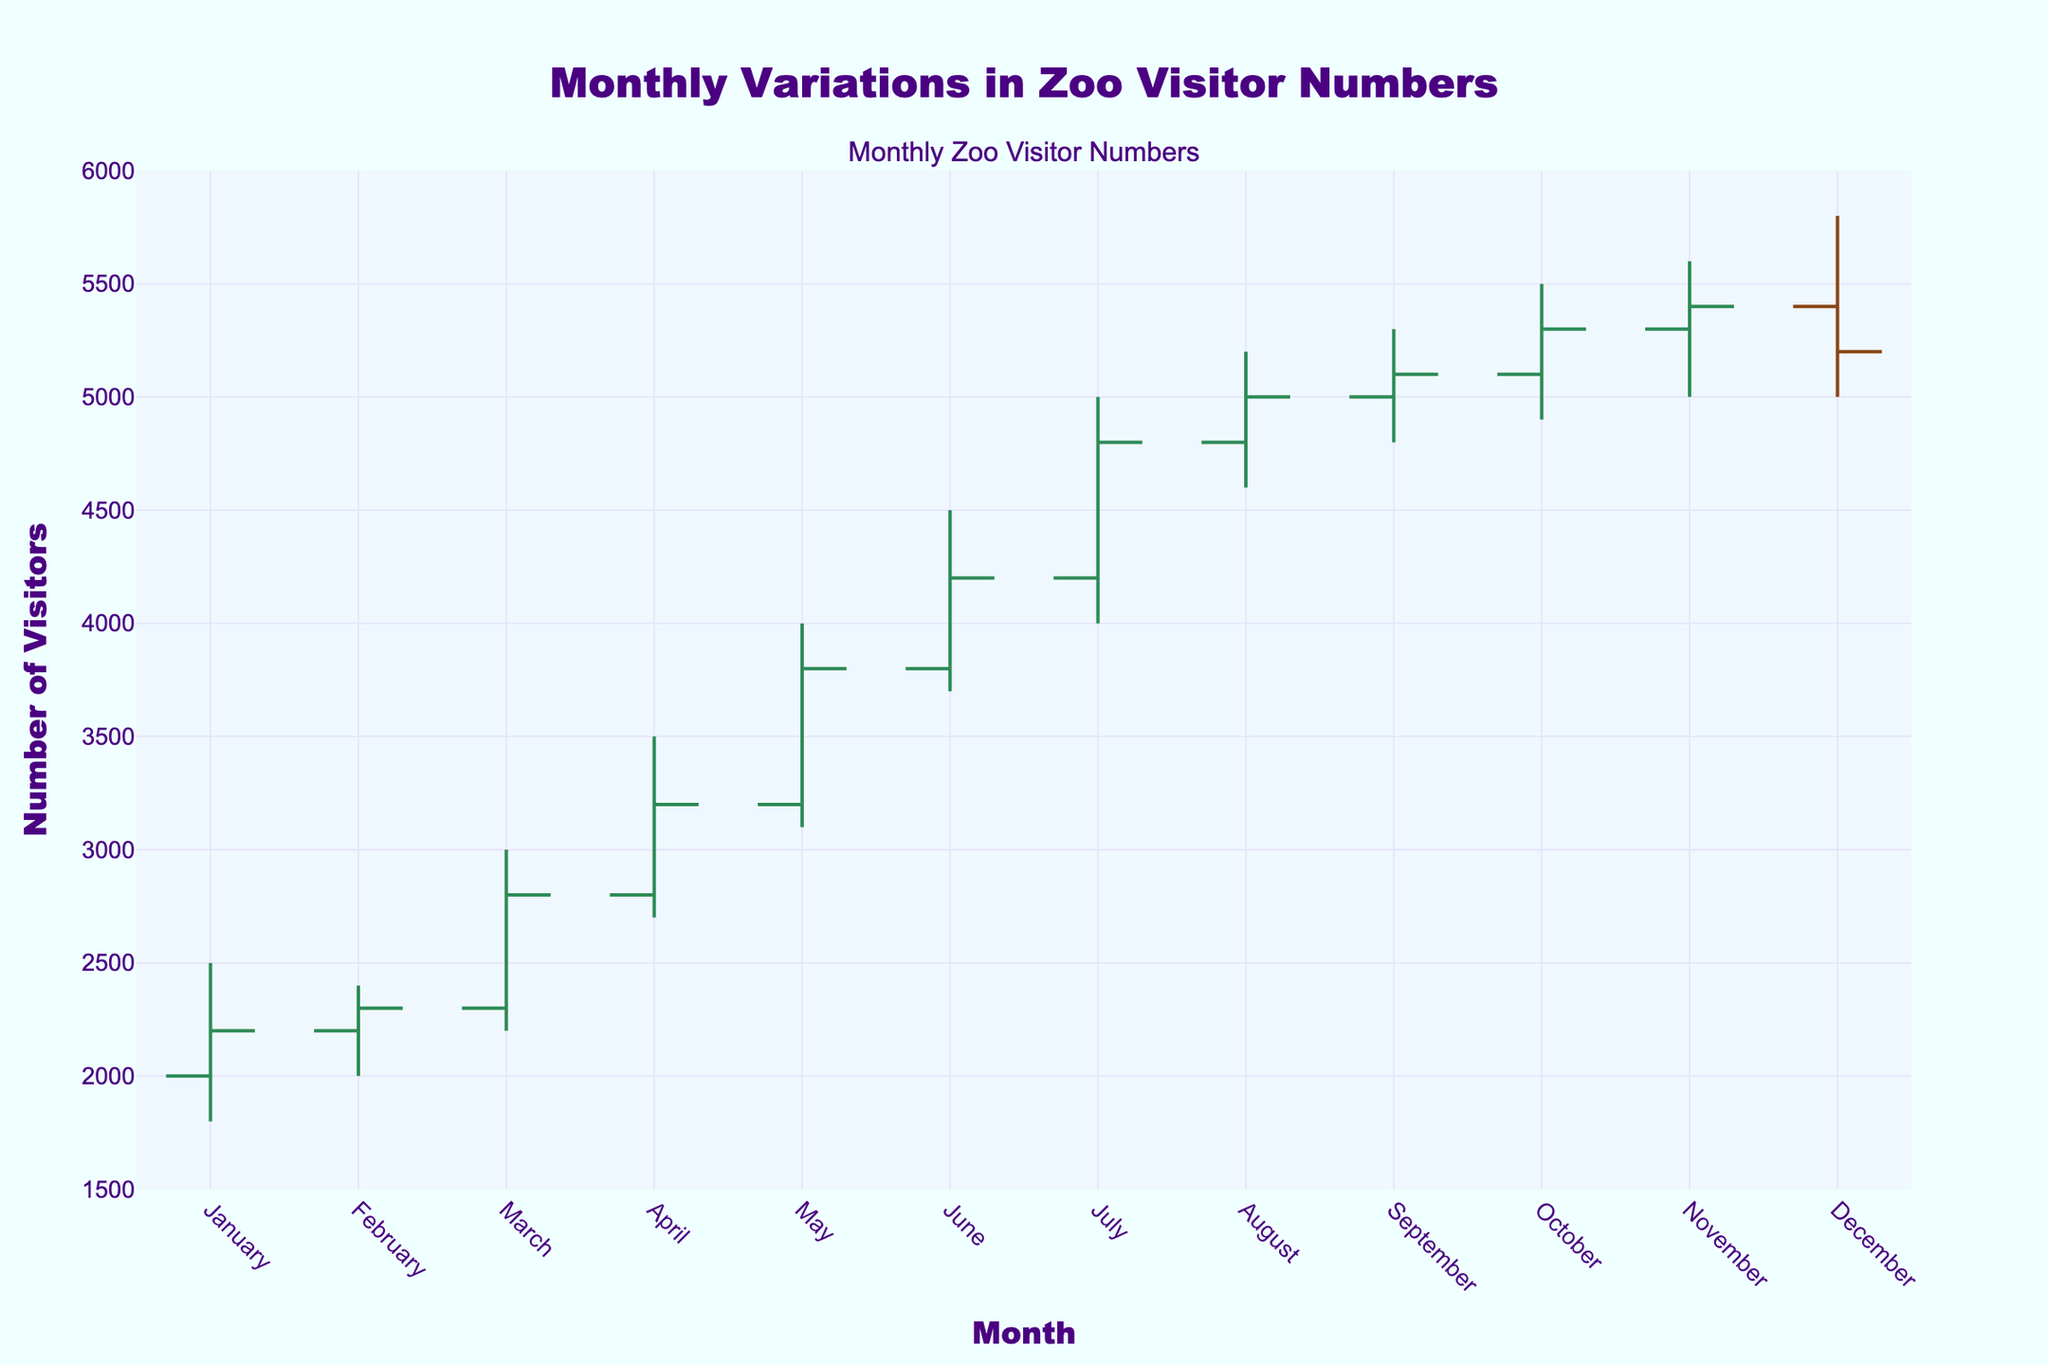What is the title of the chart? Look at the top of the chart where the title is usually located.
Answer: Monthly Variations in Zoo Visitor Numbers What are the ranges on the y-axis? The y-axis ranges from a minimum to a maximum value. Here, it is specified as 1500 to 6000.
Answer: 1500 to 6000 Which month has the highest number of visitors according to the 'High' value? Observe the 'High' value for each month to determine which month has the maximum value.
Answer: December What is the total number of months displayed in the chart? Count the number of unique months listed along the x-axis.
Answer: 12 In which month does the zoo experience the lowest visitor count according to the 'Low' value? Check the 'Low' values for each month and identify the minimum.
Answer: January During which months does the number of visitors increase when comparing the 'Open' and 'Close' values? Compare the 'Open' and 'Close' values for each month to see where 'Close' is higher. This happens in February, March, April, May, June, July, August, September, October, and November.
Answer: February, March, April, May, June, July, August, September, October, November What is the difference in the number of visitors between the highest 'High' value and the lowest 'Low' value? Subtract the lowest 'Low' value (January 1800) from the highest 'High' value (December 5800).
Answer: 4000 Which month shows the most significant drop in visitors from 'High' to 'Low'? Calculate the difference between 'High' and 'Low' for each month and identify the maximum drop.
Answer: July How does the color of the lines indicating increasing and decreasing visitor numbers differ? Observe the color of the lines for increasing movement and decreasing movement. Increasing is sea green, and decreasing is saddle brown.
Answer: Sea green (increasing), saddle brown (decreasing) During which months does the 'Close' value exceed 4000 visitors? Identify months where the 'Close' value is greater than 4000. These include June, July, August, September, October, and November.
Answer: June, July, August, September, October, November 